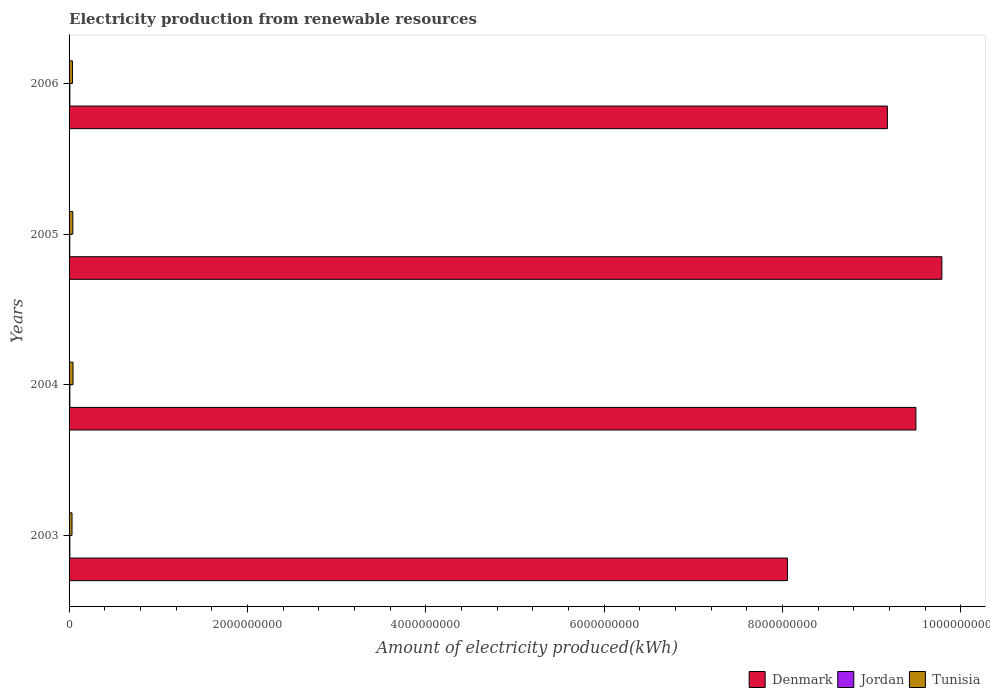How many different coloured bars are there?
Provide a short and direct response. 3. Are the number of bars on each tick of the Y-axis equal?
Your response must be concise. Yes. What is the label of the 1st group of bars from the top?
Your answer should be compact. 2006. In how many cases, is the number of bars for a given year not equal to the number of legend labels?
Ensure brevity in your answer.  0. What is the amount of electricity produced in Tunisia in 2006?
Give a very brief answer. 3.80e+07. Across all years, what is the maximum amount of electricity produced in Jordan?
Give a very brief answer. 9.00e+06. Across all years, what is the minimum amount of electricity produced in Denmark?
Provide a short and direct response. 8.06e+09. What is the total amount of electricity produced in Denmark in the graph?
Offer a terse response. 3.65e+1. What is the difference between the amount of electricity produced in Tunisia in 2003 and that in 2005?
Your response must be concise. -9.00e+06. What is the difference between the amount of electricity produced in Jordan in 2006 and the amount of electricity produced in Tunisia in 2003?
Offer a terse response. -2.40e+07. What is the average amount of electricity produced in Jordan per year?
Your answer should be compact. 8.75e+06. In the year 2005, what is the difference between the amount of electricity produced in Denmark and amount of electricity produced in Tunisia?
Make the answer very short. 9.75e+09. What is the ratio of the amount of electricity produced in Denmark in 2003 to that in 2004?
Your answer should be very brief. 0.85. Is the amount of electricity produced in Tunisia in 2004 less than that in 2005?
Provide a short and direct response. No. What is the difference between the highest and the second highest amount of electricity produced in Denmark?
Provide a succinct answer. 2.91e+08. What is the difference between the highest and the lowest amount of electricity produced in Tunisia?
Your response must be concise. 1.10e+07. Is the sum of the amount of electricity produced in Tunisia in 2004 and 2006 greater than the maximum amount of electricity produced in Denmark across all years?
Offer a terse response. No. What does the 3rd bar from the bottom in 2006 represents?
Offer a very short reply. Tunisia. Are all the bars in the graph horizontal?
Your response must be concise. Yes. What is the difference between two consecutive major ticks on the X-axis?
Offer a terse response. 2.00e+09. How many legend labels are there?
Offer a terse response. 3. What is the title of the graph?
Your answer should be compact. Electricity production from renewable resources. What is the label or title of the X-axis?
Provide a succinct answer. Amount of electricity produced(kWh). What is the label or title of the Y-axis?
Your answer should be compact. Years. What is the Amount of electricity produced(kWh) in Denmark in 2003?
Offer a terse response. 8.06e+09. What is the Amount of electricity produced(kWh) in Jordan in 2003?
Your response must be concise. 9.00e+06. What is the Amount of electricity produced(kWh) of Tunisia in 2003?
Provide a short and direct response. 3.30e+07. What is the Amount of electricity produced(kWh) in Denmark in 2004?
Offer a terse response. 9.50e+09. What is the Amount of electricity produced(kWh) of Jordan in 2004?
Keep it short and to the point. 9.00e+06. What is the Amount of electricity produced(kWh) in Tunisia in 2004?
Your answer should be compact. 4.40e+07. What is the Amount of electricity produced(kWh) of Denmark in 2005?
Provide a succinct answer. 9.79e+09. What is the Amount of electricity produced(kWh) in Jordan in 2005?
Keep it short and to the point. 8.00e+06. What is the Amount of electricity produced(kWh) of Tunisia in 2005?
Provide a succinct answer. 4.20e+07. What is the Amount of electricity produced(kWh) of Denmark in 2006?
Offer a terse response. 9.18e+09. What is the Amount of electricity produced(kWh) of Jordan in 2006?
Keep it short and to the point. 9.00e+06. What is the Amount of electricity produced(kWh) of Tunisia in 2006?
Your answer should be compact. 3.80e+07. Across all years, what is the maximum Amount of electricity produced(kWh) in Denmark?
Offer a very short reply. 9.79e+09. Across all years, what is the maximum Amount of electricity produced(kWh) of Jordan?
Your response must be concise. 9.00e+06. Across all years, what is the maximum Amount of electricity produced(kWh) in Tunisia?
Your response must be concise. 4.40e+07. Across all years, what is the minimum Amount of electricity produced(kWh) in Denmark?
Give a very brief answer. 8.06e+09. Across all years, what is the minimum Amount of electricity produced(kWh) of Jordan?
Offer a very short reply. 8.00e+06. Across all years, what is the minimum Amount of electricity produced(kWh) in Tunisia?
Offer a terse response. 3.30e+07. What is the total Amount of electricity produced(kWh) in Denmark in the graph?
Make the answer very short. 3.65e+1. What is the total Amount of electricity produced(kWh) of Jordan in the graph?
Offer a very short reply. 3.50e+07. What is the total Amount of electricity produced(kWh) of Tunisia in the graph?
Provide a succinct answer. 1.57e+08. What is the difference between the Amount of electricity produced(kWh) in Denmark in 2003 and that in 2004?
Make the answer very short. -1.44e+09. What is the difference between the Amount of electricity produced(kWh) of Tunisia in 2003 and that in 2004?
Your answer should be compact. -1.10e+07. What is the difference between the Amount of electricity produced(kWh) of Denmark in 2003 and that in 2005?
Ensure brevity in your answer.  -1.73e+09. What is the difference between the Amount of electricity produced(kWh) in Jordan in 2003 and that in 2005?
Offer a terse response. 1.00e+06. What is the difference between the Amount of electricity produced(kWh) of Tunisia in 2003 and that in 2005?
Offer a very short reply. -9.00e+06. What is the difference between the Amount of electricity produced(kWh) in Denmark in 2003 and that in 2006?
Provide a short and direct response. -1.12e+09. What is the difference between the Amount of electricity produced(kWh) of Jordan in 2003 and that in 2006?
Your answer should be very brief. 0. What is the difference between the Amount of electricity produced(kWh) of Tunisia in 2003 and that in 2006?
Provide a short and direct response. -5.00e+06. What is the difference between the Amount of electricity produced(kWh) in Denmark in 2004 and that in 2005?
Provide a succinct answer. -2.91e+08. What is the difference between the Amount of electricity produced(kWh) in Tunisia in 2004 and that in 2005?
Provide a succinct answer. 2.00e+06. What is the difference between the Amount of electricity produced(kWh) of Denmark in 2004 and that in 2006?
Offer a very short reply. 3.20e+08. What is the difference between the Amount of electricity produced(kWh) in Denmark in 2005 and that in 2006?
Your response must be concise. 6.11e+08. What is the difference between the Amount of electricity produced(kWh) of Jordan in 2005 and that in 2006?
Keep it short and to the point. -1.00e+06. What is the difference between the Amount of electricity produced(kWh) of Tunisia in 2005 and that in 2006?
Provide a succinct answer. 4.00e+06. What is the difference between the Amount of electricity produced(kWh) of Denmark in 2003 and the Amount of electricity produced(kWh) of Jordan in 2004?
Your answer should be compact. 8.05e+09. What is the difference between the Amount of electricity produced(kWh) of Denmark in 2003 and the Amount of electricity produced(kWh) of Tunisia in 2004?
Make the answer very short. 8.01e+09. What is the difference between the Amount of electricity produced(kWh) of Jordan in 2003 and the Amount of electricity produced(kWh) of Tunisia in 2004?
Keep it short and to the point. -3.50e+07. What is the difference between the Amount of electricity produced(kWh) of Denmark in 2003 and the Amount of electricity produced(kWh) of Jordan in 2005?
Provide a short and direct response. 8.05e+09. What is the difference between the Amount of electricity produced(kWh) of Denmark in 2003 and the Amount of electricity produced(kWh) of Tunisia in 2005?
Give a very brief answer. 8.02e+09. What is the difference between the Amount of electricity produced(kWh) in Jordan in 2003 and the Amount of electricity produced(kWh) in Tunisia in 2005?
Give a very brief answer. -3.30e+07. What is the difference between the Amount of electricity produced(kWh) of Denmark in 2003 and the Amount of electricity produced(kWh) of Jordan in 2006?
Your response must be concise. 8.05e+09. What is the difference between the Amount of electricity produced(kWh) in Denmark in 2003 and the Amount of electricity produced(kWh) in Tunisia in 2006?
Make the answer very short. 8.02e+09. What is the difference between the Amount of electricity produced(kWh) in Jordan in 2003 and the Amount of electricity produced(kWh) in Tunisia in 2006?
Your answer should be very brief. -2.90e+07. What is the difference between the Amount of electricity produced(kWh) of Denmark in 2004 and the Amount of electricity produced(kWh) of Jordan in 2005?
Your response must be concise. 9.49e+09. What is the difference between the Amount of electricity produced(kWh) of Denmark in 2004 and the Amount of electricity produced(kWh) of Tunisia in 2005?
Offer a terse response. 9.46e+09. What is the difference between the Amount of electricity produced(kWh) in Jordan in 2004 and the Amount of electricity produced(kWh) in Tunisia in 2005?
Provide a short and direct response. -3.30e+07. What is the difference between the Amount of electricity produced(kWh) of Denmark in 2004 and the Amount of electricity produced(kWh) of Jordan in 2006?
Give a very brief answer. 9.49e+09. What is the difference between the Amount of electricity produced(kWh) of Denmark in 2004 and the Amount of electricity produced(kWh) of Tunisia in 2006?
Make the answer very short. 9.46e+09. What is the difference between the Amount of electricity produced(kWh) of Jordan in 2004 and the Amount of electricity produced(kWh) of Tunisia in 2006?
Make the answer very short. -2.90e+07. What is the difference between the Amount of electricity produced(kWh) in Denmark in 2005 and the Amount of electricity produced(kWh) in Jordan in 2006?
Keep it short and to the point. 9.78e+09. What is the difference between the Amount of electricity produced(kWh) in Denmark in 2005 and the Amount of electricity produced(kWh) in Tunisia in 2006?
Offer a very short reply. 9.75e+09. What is the difference between the Amount of electricity produced(kWh) in Jordan in 2005 and the Amount of electricity produced(kWh) in Tunisia in 2006?
Provide a succinct answer. -3.00e+07. What is the average Amount of electricity produced(kWh) in Denmark per year?
Ensure brevity in your answer.  9.13e+09. What is the average Amount of electricity produced(kWh) of Jordan per year?
Offer a very short reply. 8.75e+06. What is the average Amount of electricity produced(kWh) of Tunisia per year?
Provide a short and direct response. 3.92e+07. In the year 2003, what is the difference between the Amount of electricity produced(kWh) in Denmark and Amount of electricity produced(kWh) in Jordan?
Give a very brief answer. 8.05e+09. In the year 2003, what is the difference between the Amount of electricity produced(kWh) of Denmark and Amount of electricity produced(kWh) of Tunisia?
Offer a very short reply. 8.02e+09. In the year 2003, what is the difference between the Amount of electricity produced(kWh) of Jordan and Amount of electricity produced(kWh) of Tunisia?
Offer a terse response. -2.40e+07. In the year 2004, what is the difference between the Amount of electricity produced(kWh) in Denmark and Amount of electricity produced(kWh) in Jordan?
Your response must be concise. 9.49e+09. In the year 2004, what is the difference between the Amount of electricity produced(kWh) in Denmark and Amount of electricity produced(kWh) in Tunisia?
Keep it short and to the point. 9.45e+09. In the year 2004, what is the difference between the Amount of electricity produced(kWh) in Jordan and Amount of electricity produced(kWh) in Tunisia?
Provide a succinct answer. -3.50e+07. In the year 2005, what is the difference between the Amount of electricity produced(kWh) in Denmark and Amount of electricity produced(kWh) in Jordan?
Make the answer very short. 9.78e+09. In the year 2005, what is the difference between the Amount of electricity produced(kWh) in Denmark and Amount of electricity produced(kWh) in Tunisia?
Ensure brevity in your answer.  9.75e+09. In the year 2005, what is the difference between the Amount of electricity produced(kWh) in Jordan and Amount of electricity produced(kWh) in Tunisia?
Ensure brevity in your answer.  -3.40e+07. In the year 2006, what is the difference between the Amount of electricity produced(kWh) of Denmark and Amount of electricity produced(kWh) of Jordan?
Your answer should be compact. 9.17e+09. In the year 2006, what is the difference between the Amount of electricity produced(kWh) of Denmark and Amount of electricity produced(kWh) of Tunisia?
Provide a short and direct response. 9.14e+09. In the year 2006, what is the difference between the Amount of electricity produced(kWh) of Jordan and Amount of electricity produced(kWh) of Tunisia?
Give a very brief answer. -2.90e+07. What is the ratio of the Amount of electricity produced(kWh) of Denmark in 2003 to that in 2004?
Your answer should be compact. 0.85. What is the ratio of the Amount of electricity produced(kWh) of Tunisia in 2003 to that in 2004?
Offer a terse response. 0.75. What is the ratio of the Amount of electricity produced(kWh) of Denmark in 2003 to that in 2005?
Offer a very short reply. 0.82. What is the ratio of the Amount of electricity produced(kWh) of Jordan in 2003 to that in 2005?
Your answer should be compact. 1.12. What is the ratio of the Amount of electricity produced(kWh) of Tunisia in 2003 to that in 2005?
Keep it short and to the point. 0.79. What is the ratio of the Amount of electricity produced(kWh) in Denmark in 2003 to that in 2006?
Your answer should be compact. 0.88. What is the ratio of the Amount of electricity produced(kWh) of Jordan in 2003 to that in 2006?
Provide a succinct answer. 1. What is the ratio of the Amount of electricity produced(kWh) of Tunisia in 2003 to that in 2006?
Keep it short and to the point. 0.87. What is the ratio of the Amount of electricity produced(kWh) of Denmark in 2004 to that in 2005?
Provide a succinct answer. 0.97. What is the ratio of the Amount of electricity produced(kWh) of Jordan in 2004 to that in 2005?
Provide a short and direct response. 1.12. What is the ratio of the Amount of electricity produced(kWh) of Tunisia in 2004 to that in 2005?
Your answer should be very brief. 1.05. What is the ratio of the Amount of electricity produced(kWh) in Denmark in 2004 to that in 2006?
Your answer should be very brief. 1.03. What is the ratio of the Amount of electricity produced(kWh) of Jordan in 2004 to that in 2006?
Ensure brevity in your answer.  1. What is the ratio of the Amount of electricity produced(kWh) of Tunisia in 2004 to that in 2006?
Your response must be concise. 1.16. What is the ratio of the Amount of electricity produced(kWh) of Denmark in 2005 to that in 2006?
Provide a succinct answer. 1.07. What is the ratio of the Amount of electricity produced(kWh) in Jordan in 2005 to that in 2006?
Your answer should be very brief. 0.89. What is the ratio of the Amount of electricity produced(kWh) of Tunisia in 2005 to that in 2006?
Make the answer very short. 1.11. What is the difference between the highest and the second highest Amount of electricity produced(kWh) in Denmark?
Your answer should be very brief. 2.91e+08. What is the difference between the highest and the second highest Amount of electricity produced(kWh) of Jordan?
Keep it short and to the point. 0. What is the difference between the highest and the second highest Amount of electricity produced(kWh) in Tunisia?
Offer a very short reply. 2.00e+06. What is the difference between the highest and the lowest Amount of electricity produced(kWh) in Denmark?
Your answer should be very brief. 1.73e+09. What is the difference between the highest and the lowest Amount of electricity produced(kWh) in Jordan?
Keep it short and to the point. 1.00e+06. What is the difference between the highest and the lowest Amount of electricity produced(kWh) of Tunisia?
Offer a very short reply. 1.10e+07. 